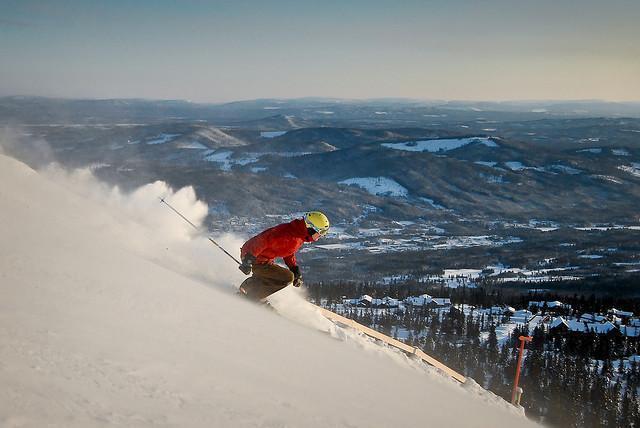What type of region is the man visiting?
Select the accurate answer and provide justification: `Answer: choice
Rationale: srationale.`
Options: Desert, mountain, tropical, aquatic. Answer: mountain.
Rationale: The man is skiing downhill from the top of a snowy hill. 